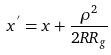Convert formula to latex. <formula><loc_0><loc_0><loc_500><loc_500>x ^ { ^ { \prime } } = x + \frac { \rho ^ { 2 } } { 2 R R _ { g } }</formula> 